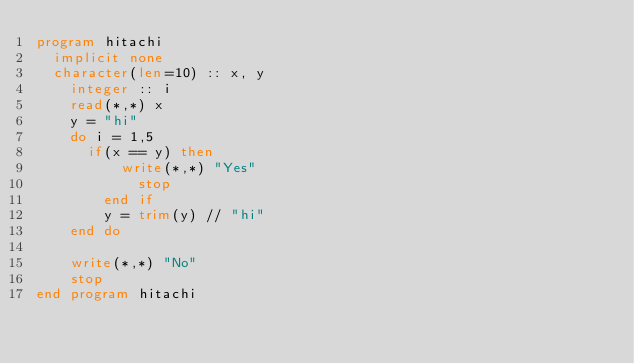<code> <loc_0><loc_0><loc_500><loc_500><_FORTRAN_>program hitachi
	implicit none
	character(len=10) :: x, y
    integer :: i
    read(*,*) x
    y = "hi"
    do i = 1,5
    	if(x == y) then
        	write(*,*) "Yes"
            stop
        end if
        y = trim(y) // "hi"
    end do
    
    write(*,*) "No"
    stop
end program hitachi</code> 